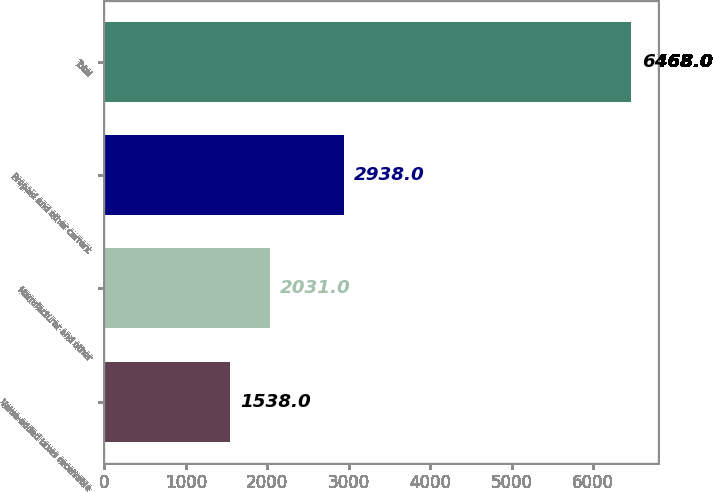Convert chart to OTSL. <chart><loc_0><loc_0><loc_500><loc_500><bar_chart><fcel>Value-added taxes receivable<fcel>Manufacturer and other<fcel>Prepaid and other current<fcel>Total<nl><fcel>1538<fcel>2031<fcel>2938<fcel>6468<nl></chart> 